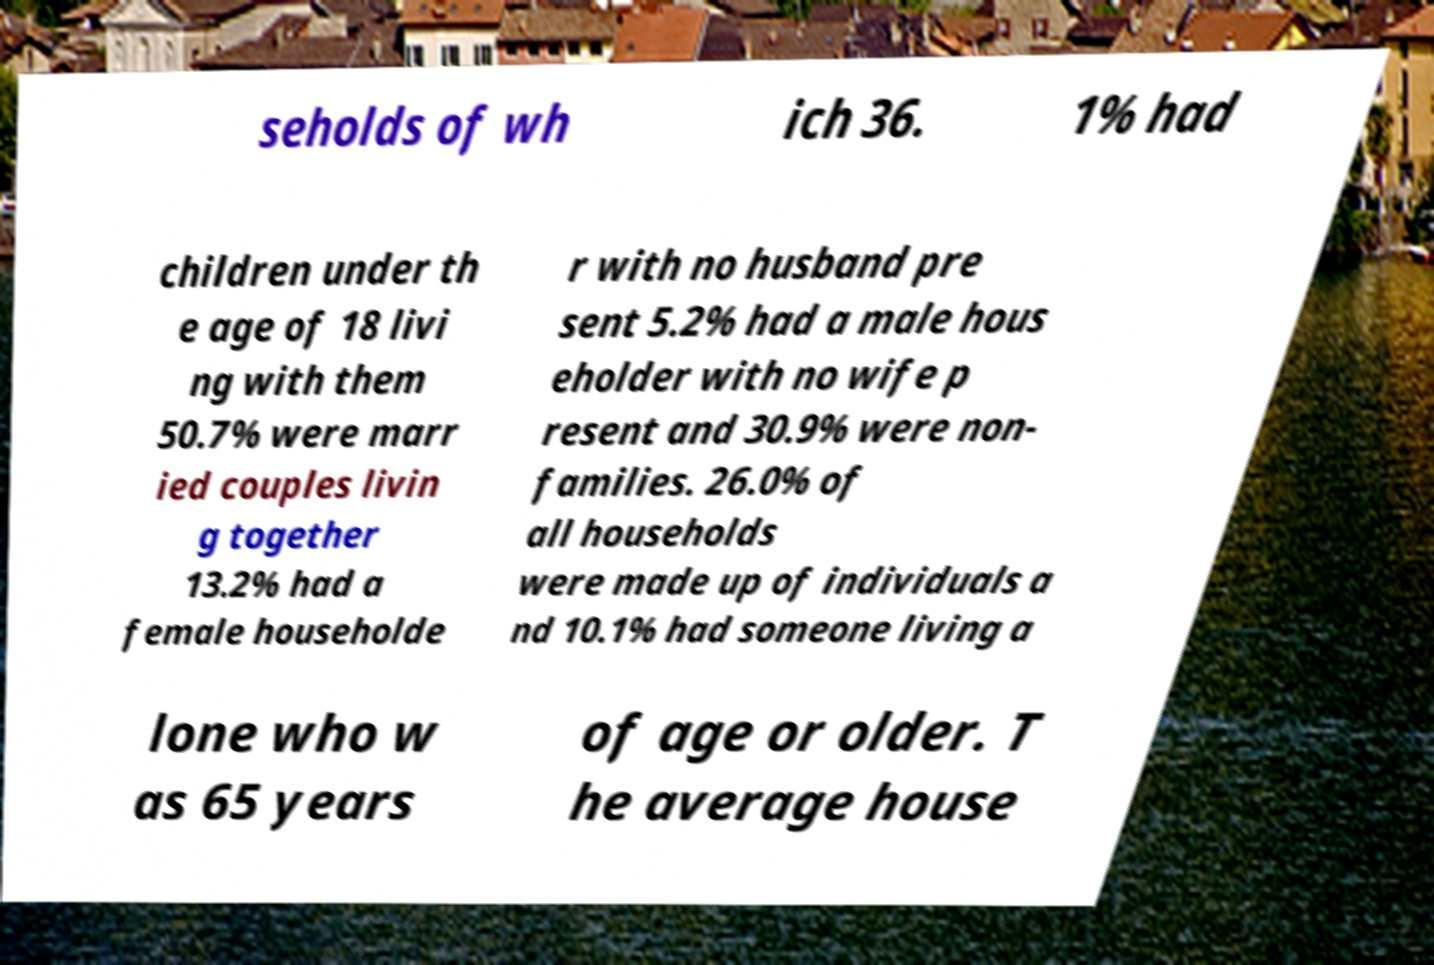Can you read and provide the text displayed in the image?This photo seems to have some interesting text. Can you extract and type it out for me? seholds of wh ich 36. 1% had children under th e age of 18 livi ng with them 50.7% were marr ied couples livin g together 13.2% had a female householde r with no husband pre sent 5.2% had a male hous eholder with no wife p resent and 30.9% were non- families. 26.0% of all households were made up of individuals a nd 10.1% had someone living a lone who w as 65 years of age or older. T he average house 